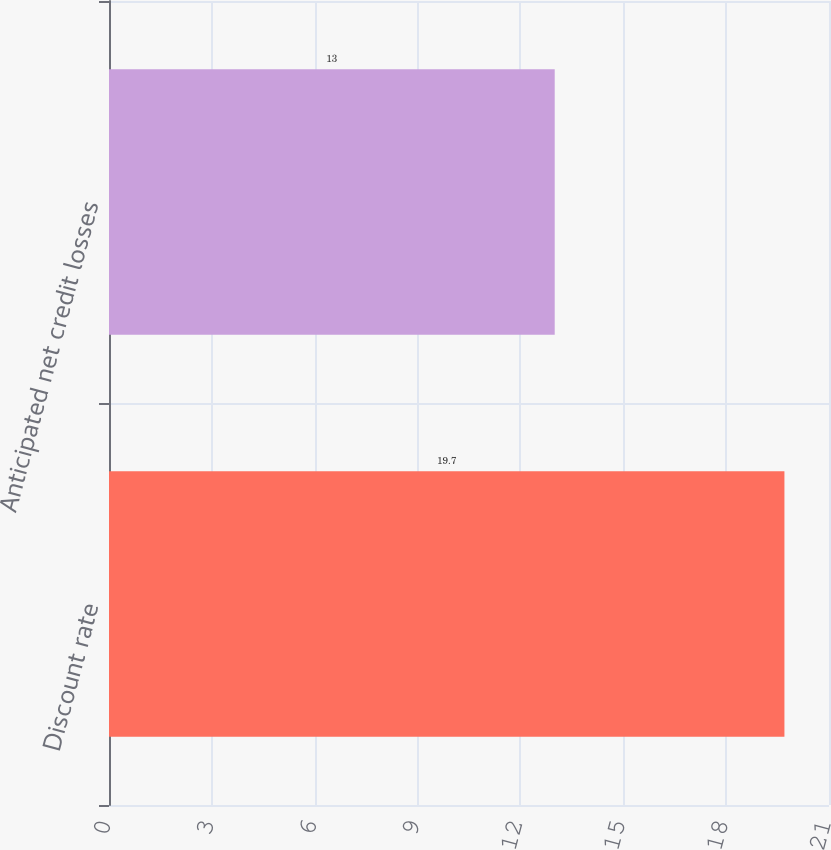Convert chart. <chart><loc_0><loc_0><loc_500><loc_500><bar_chart><fcel>Discount rate<fcel>Anticipated net credit losses<nl><fcel>19.7<fcel>13<nl></chart> 